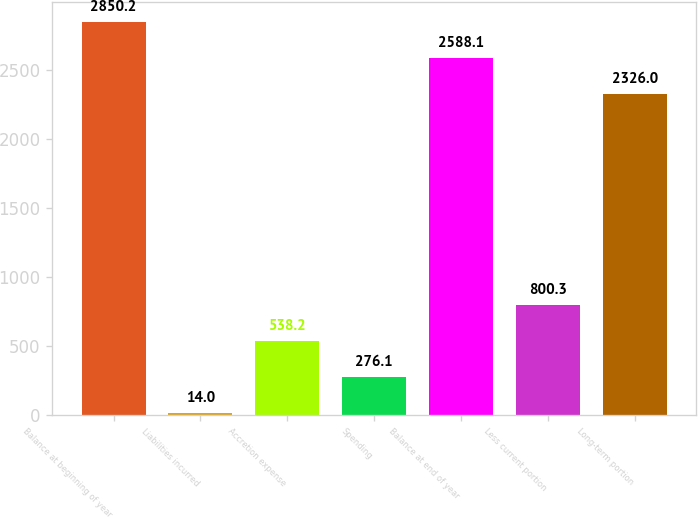Convert chart. <chart><loc_0><loc_0><loc_500><loc_500><bar_chart><fcel>Balance at beginning of year<fcel>Liabilities incurred<fcel>Accretion expense<fcel>Spending<fcel>Balance at end of year<fcel>Less current portion<fcel>Long-term portion<nl><fcel>2850.2<fcel>14<fcel>538.2<fcel>276.1<fcel>2588.1<fcel>800.3<fcel>2326<nl></chart> 